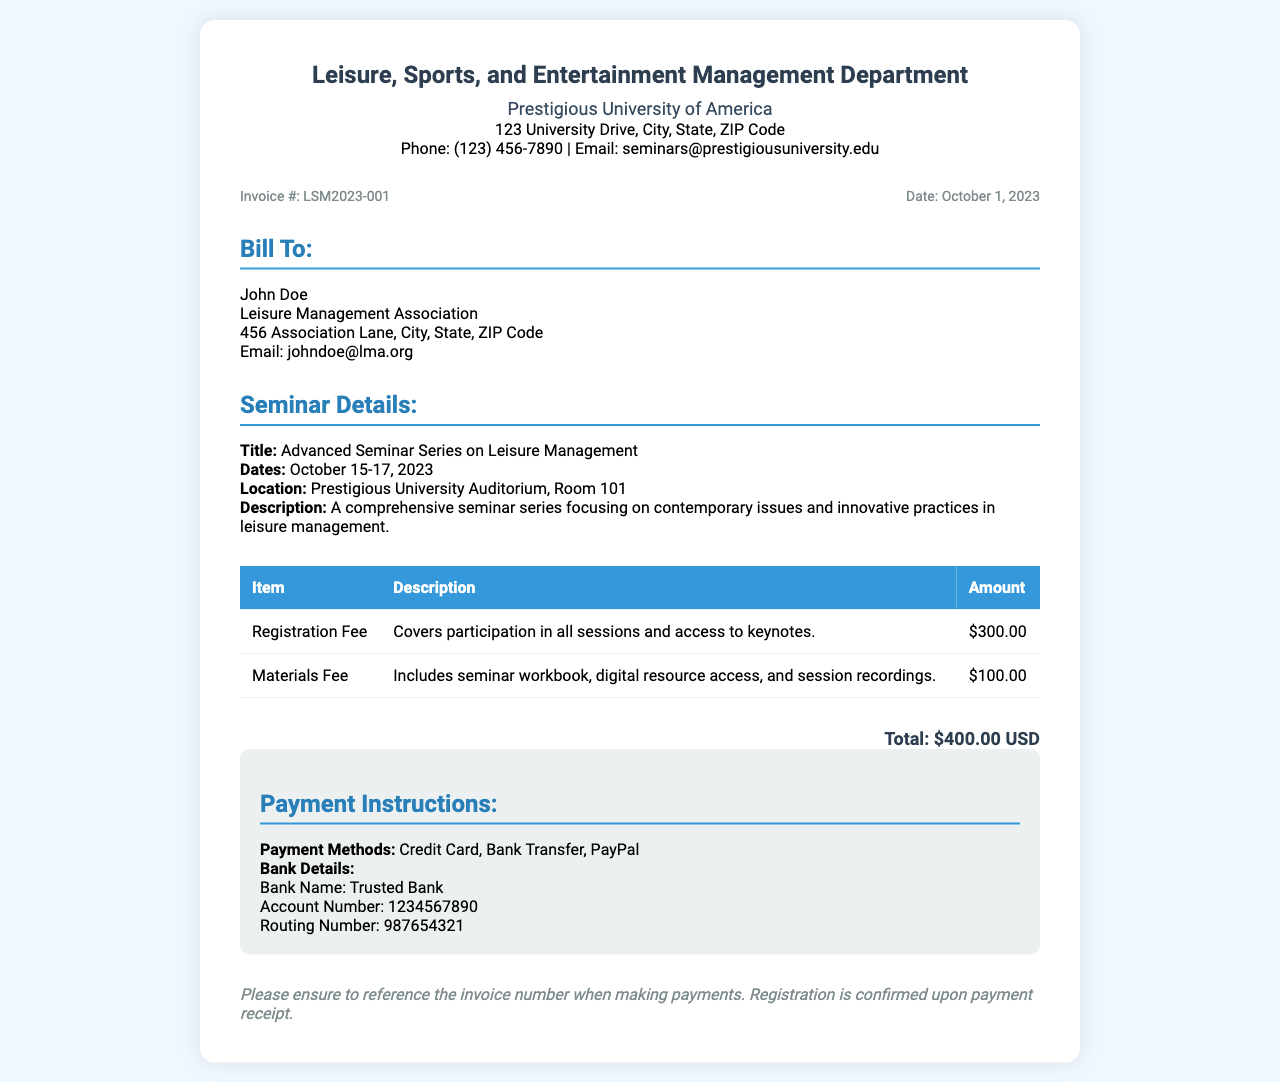What is the title of the seminar? The title of the seminar is provided under the seminar details section.
Answer: Advanced Seminar Series on Leisure Management What are the dates of the seminar? The seminar dates are listed in the seminar details section.
Answer: October 15-17, 2023 What is the total amount due? The total amount is stated clearly in the total section of the invoice.
Answer: $400.00 USD Who is the invoice billed to? The recipient's information is provided in the bill to section of the invoice.
Answer: John Doe What is included in the materials fee? The description of the materials fee outlines what is covered.
Answer: Seminar workbook, digital resource access, and session recordings What payment methods are accepted? The payment instructions specify acceptable payment methods.
Answer: Credit Card, Bank Transfer, PayPal What does the registration fee cover? The invoice details what the registration fee entails in its description.
Answer: Participation in all sessions and access to keynotes What bank details are provided for payment? The payment instructions include specific bank details for wire transfers.
Answer: Trusted Bank, Account Number: 1234567890, Routing Number: 987654321 What is the invoice number? The invoice number is clearly stated in the invoice details section.
Answer: LSM2023-001 